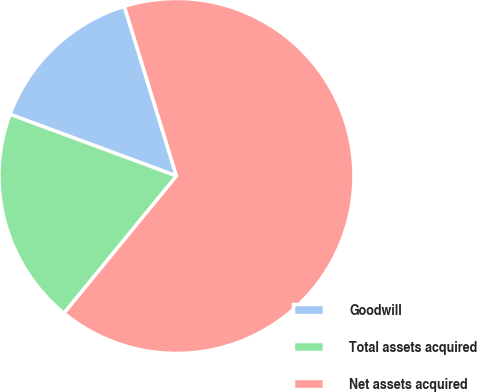Convert chart. <chart><loc_0><loc_0><loc_500><loc_500><pie_chart><fcel>Goodwill<fcel>Total assets acquired<fcel>Net assets acquired<nl><fcel>14.61%<fcel>19.72%<fcel>65.67%<nl></chart> 